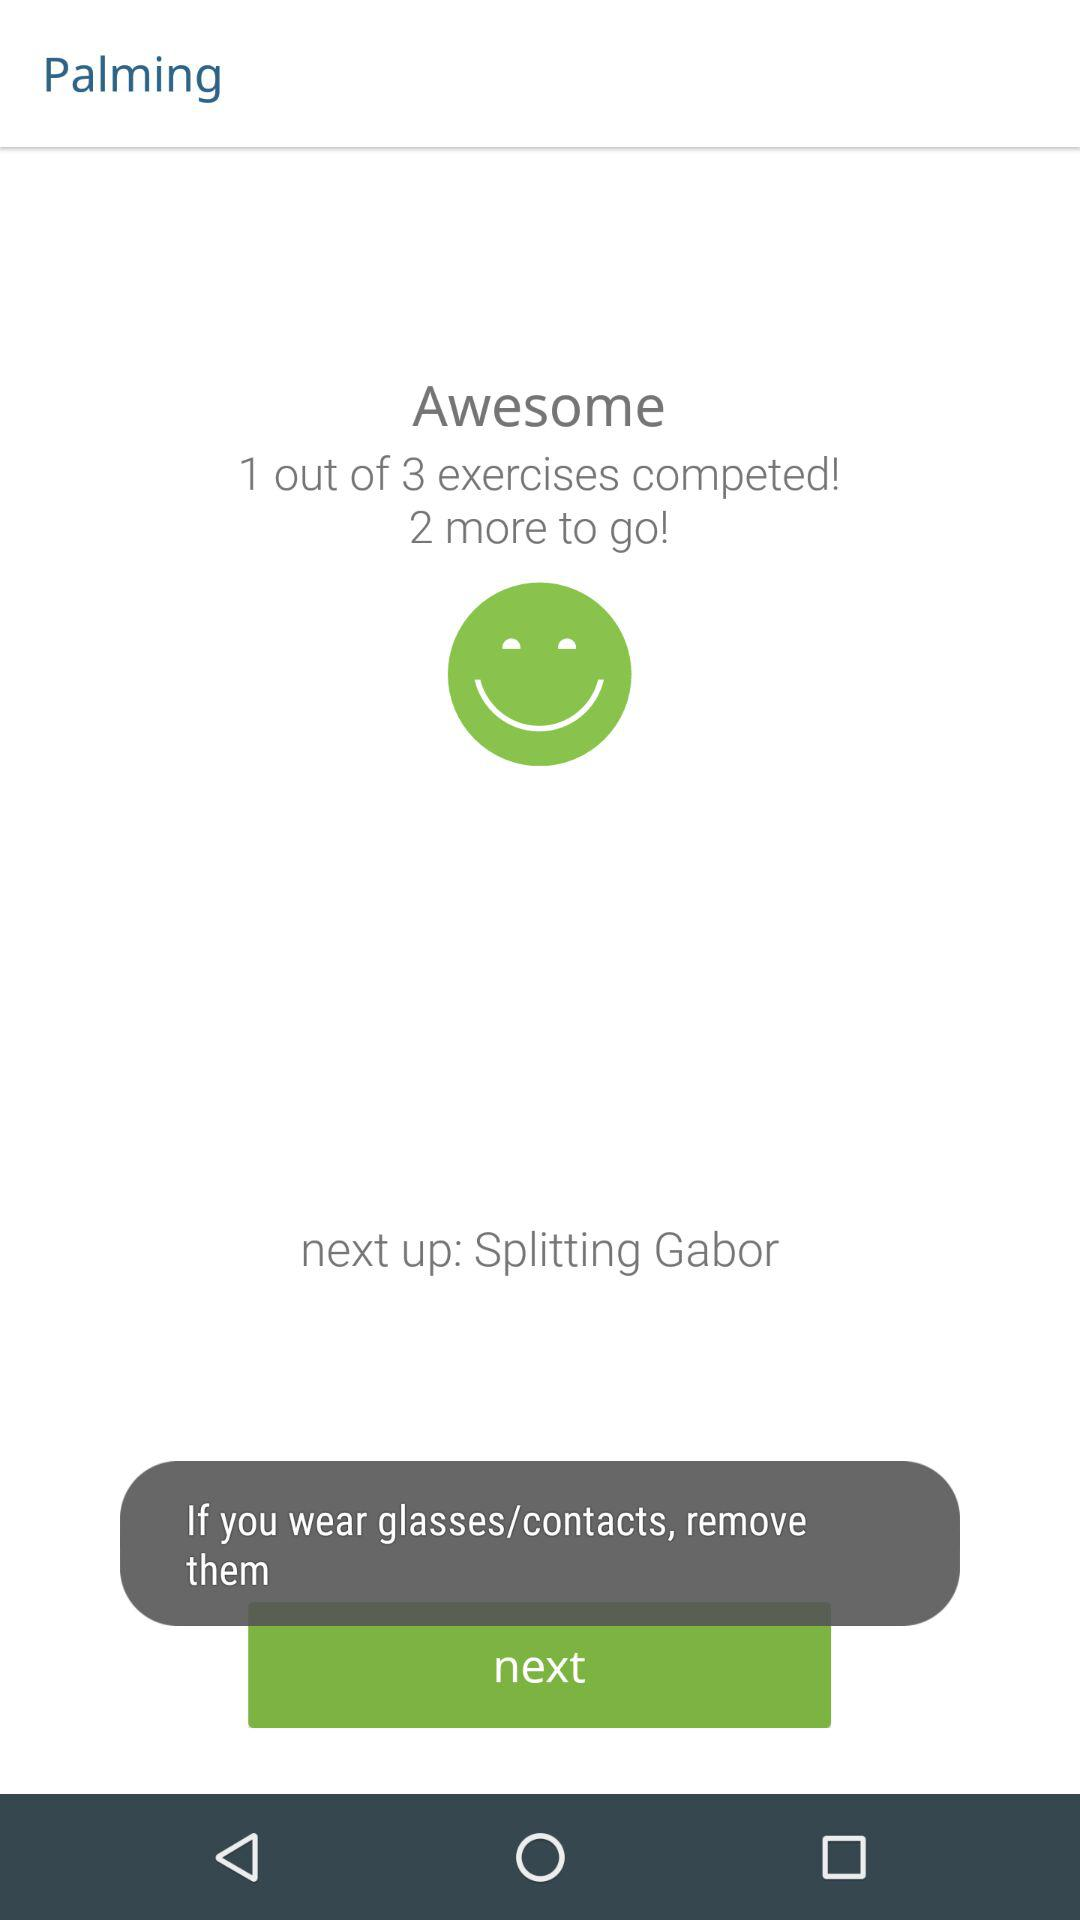What's the next exercise? The next exercise is "Splitting Gabor". 